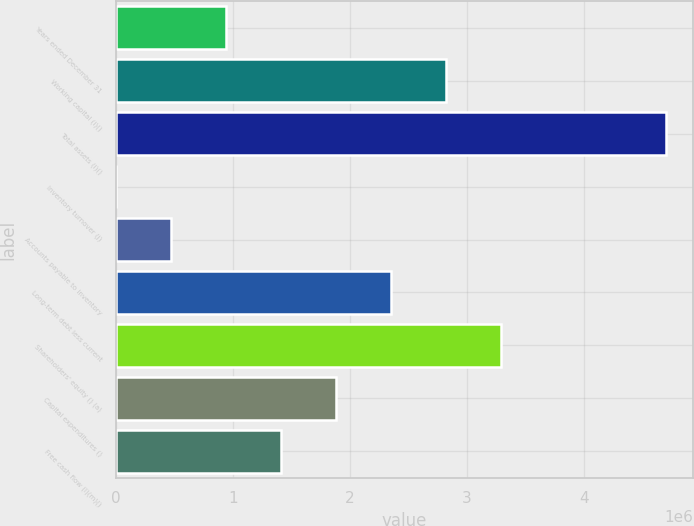Convert chart to OTSL. <chart><loc_0><loc_0><loc_500><loc_500><bar_chart><fcel>Years ended December 31<fcel>Working capital (i)()<fcel>Total assets (i)()<fcel>Inventory turnover (j)<fcel>Accounts payable to inventory<fcel>Long-term debt less current<fcel>Shareholders' equity () (a)<fcel>Capital expenditures ()<fcel>Free cash flow (l)(m)()<nl><fcel>939108<fcel>2.81732e+06<fcel>4.69554e+06<fcel>1.4<fcel>469555<fcel>2.34777e+06<fcel>3.28688e+06<fcel>1.87822e+06<fcel>1.40866e+06<nl></chart> 